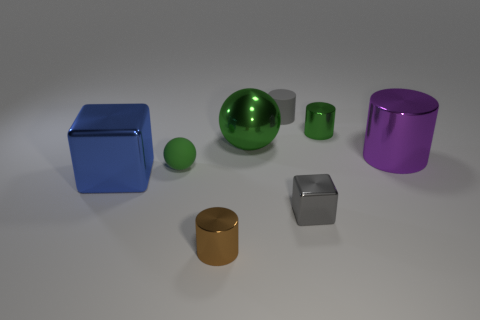How many objects are in the image, and can you categorize them by shape? There are seven objects in the image: one sphere, two cylinders, and four cubes. The sphere is green, the cylinders come in purple and gold, and the cubes are in blue, green, silver, and a smaller dark blue. Which object seems closest to the point of view? The silver cube appears to be closest to the point of view, based on its size and position relative to the other objects. 